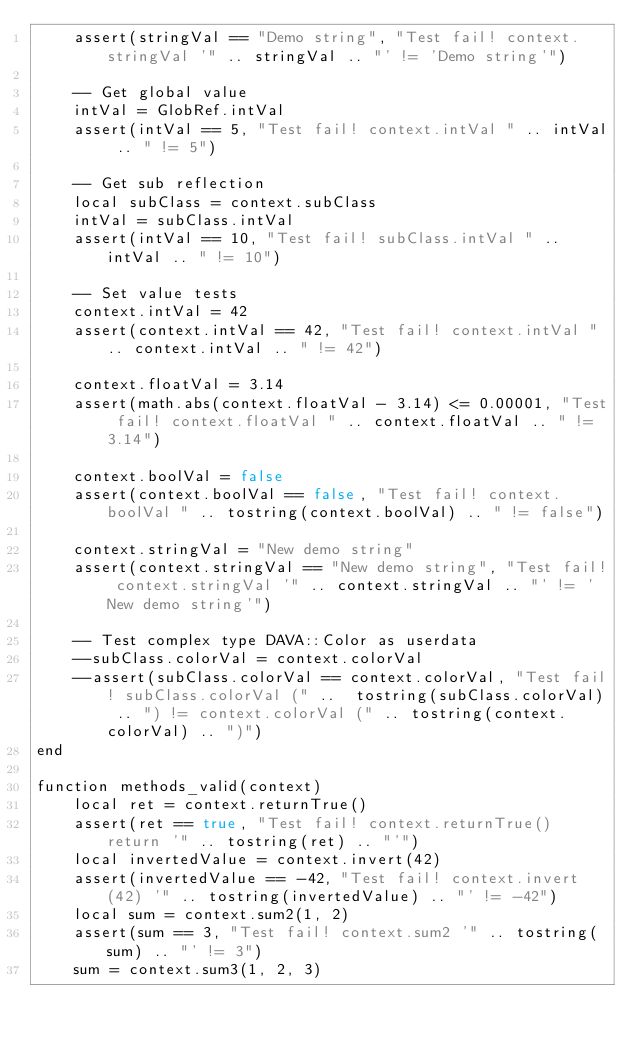<code> <loc_0><loc_0><loc_500><loc_500><_C++_>    assert(stringVal == "Demo string", "Test fail! context.stringVal '" .. stringVal .. "' != 'Demo string'")

    -- Get global value
    intVal = GlobRef.intVal
    assert(intVal == 5, "Test fail! context.intVal " .. intVal .. " != 5")

    -- Get sub reflection
    local subClass = context.subClass
    intVal = subClass.intVal
    assert(intVal == 10, "Test fail! subClass.intVal " .. intVal .. " != 10")

    -- Set value tests
    context.intVal = 42
    assert(context.intVal == 42, "Test fail! context.intVal " .. context.intVal .. " != 42")

    context.floatVal = 3.14
    assert(math.abs(context.floatVal - 3.14) <= 0.00001, "Test fail! context.floatVal " .. context.floatVal .. " != 3.14")

    context.boolVal = false
    assert(context.boolVal == false, "Test fail! context.boolVal " .. tostring(context.boolVal) .. " != false")

    context.stringVal = "New demo string"
    assert(context.stringVal == "New demo string", "Test fail! context.stringVal '" .. context.stringVal .. "' != 'New demo string'")

    -- Test complex type DAVA::Color as userdata
    --subClass.colorVal = context.colorVal
    --assert(subClass.colorVal == context.colorVal, "Test fail! subClass.colorVal (" ..  tostring(subClass.colorVal) .. ") != context.colorVal (" .. tostring(context.colorVal) .. ")")
end

function methods_valid(context)
    local ret = context.returnTrue()
    assert(ret == true, "Test fail! context.returnTrue() return '" .. tostring(ret) .. "'")
    local invertedValue = context.invert(42)
    assert(invertedValue == -42, "Test fail! context.invert(42) '" .. tostring(invertedValue) .. "' != -42")
    local sum = context.sum2(1, 2)
    assert(sum == 3, "Test fail! context.sum2 '" .. tostring(sum) .. "' != 3")
    sum = context.sum3(1, 2, 3)</code> 